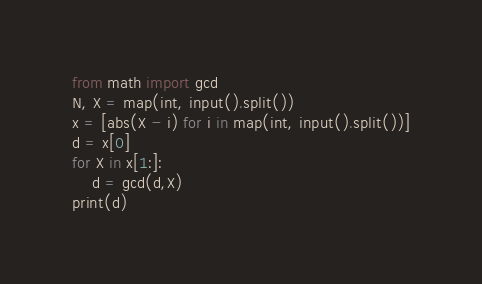<code> <loc_0><loc_0><loc_500><loc_500><_Python_>from math import gcd
N, X = map(int, input().split())
x = [abs(X - i) for i in map(int, input().split())]
d = x[0]
for X in x[1:]:
    d = gcd(d,X)
print(d)</code> 